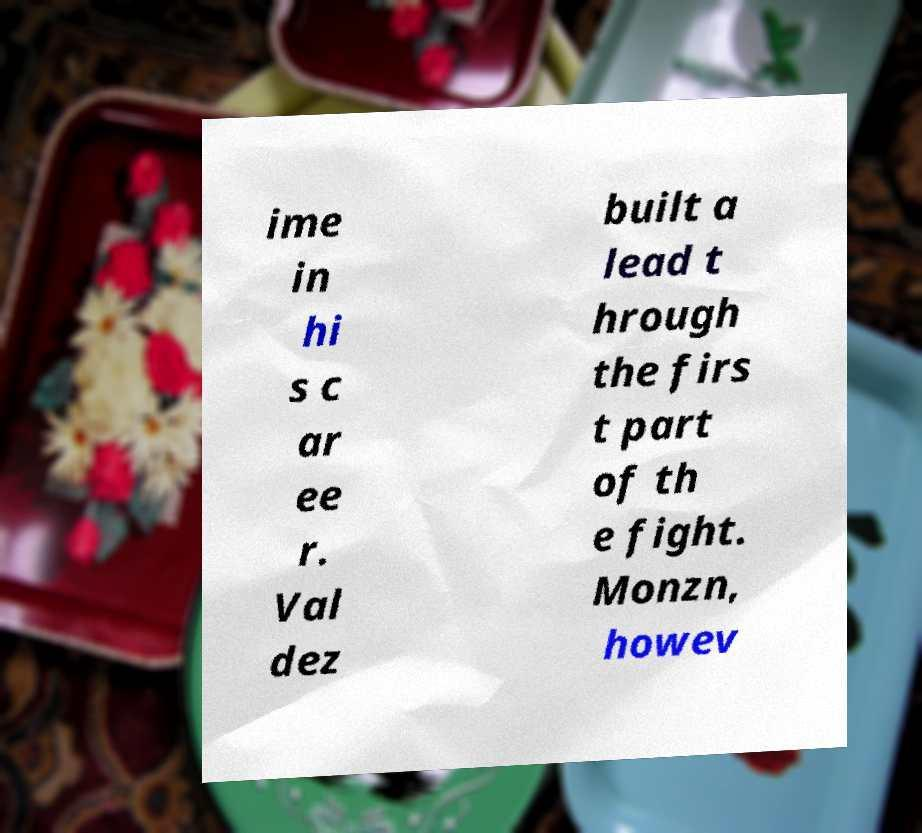What messages or text are displayed in this image? I need them in a readable, typed format. ime in hi s c ar ee r. Val dez built a lead t hrough the firs t part of th e fight. Monzn, howev 